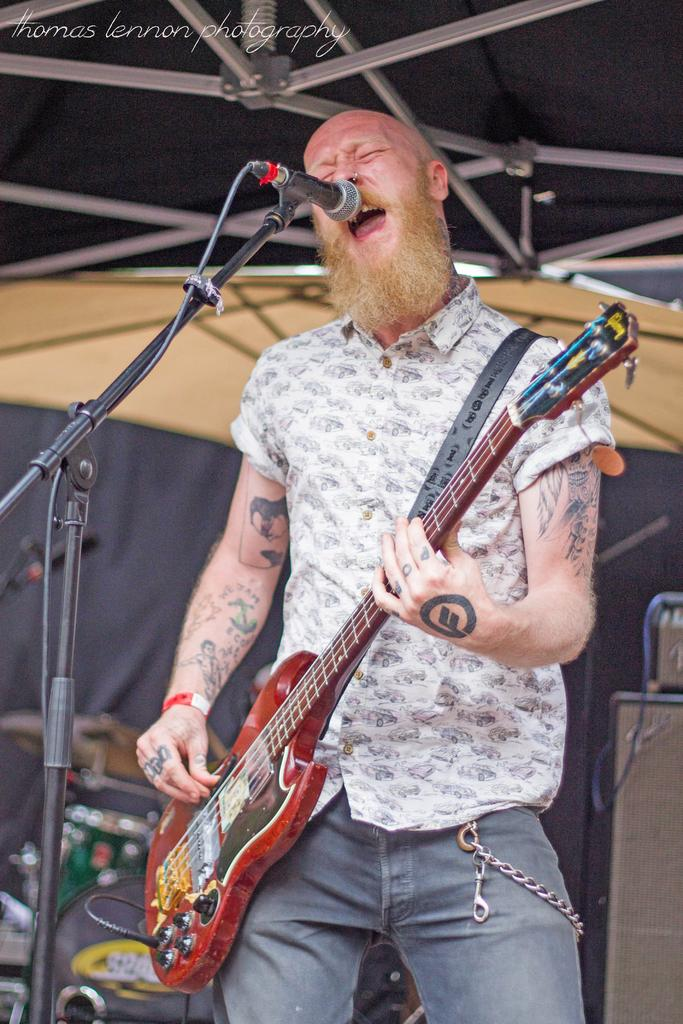What is the man in the image doing? The man is singing in the image. What instrument is the man holding? The man is holding a guitar. What object is the man using to amplify his voice? There is a microphone in the image. What is used to hold the guitar when the man is not playing it? There is a guitar stand in the image. What can be seen in the background of the image? There are musical instruments and a cloth in the background of the image. How does the man protect himself from the rainstorm in the image? There is no rainstorm present in the image; it is an indoor setting with no indication of rain. What type of pump is used to support the man's performance in the image? There is no pump present in the image, and the man's performance is not supported by any such device. 